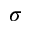<formula> <loc_0><loc_0><loc_500><loc_500>\sigma</formula> 